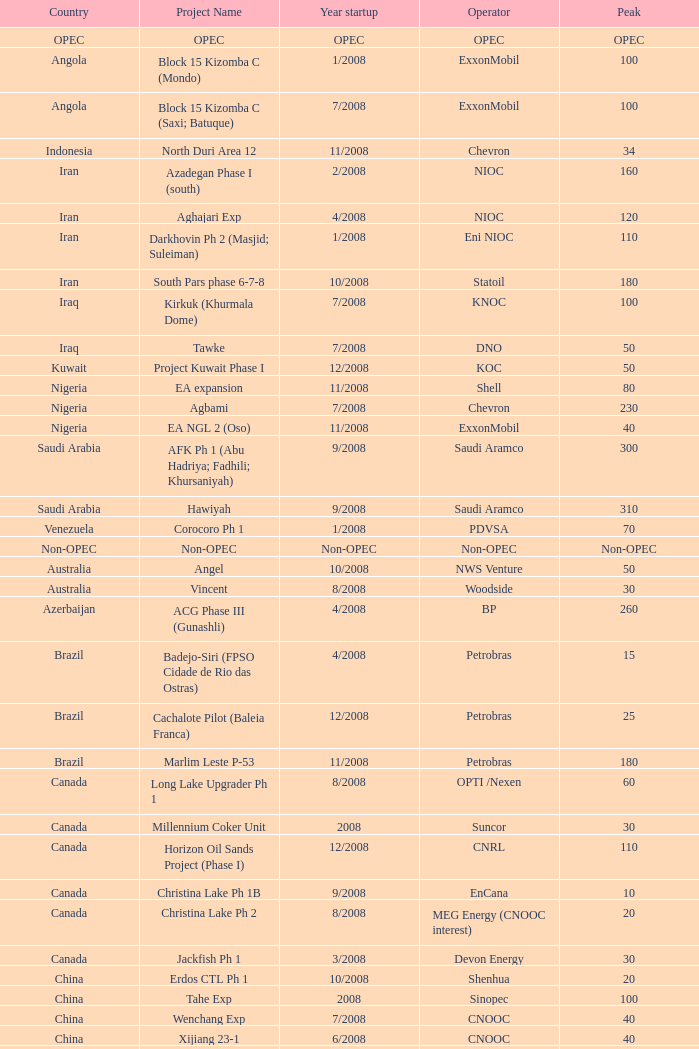What is the Project Name with a Country that is opec? OPEC. 